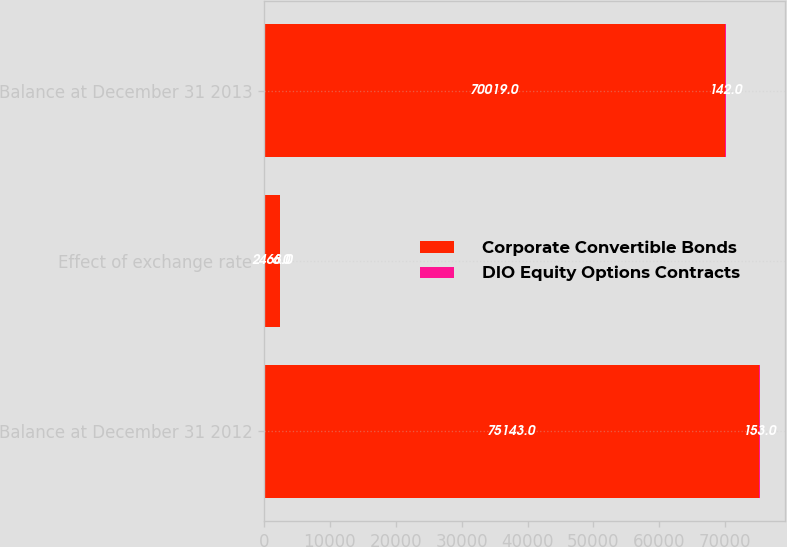Convert chart to OTSL. <chart><loc_0><loc_0><loc_500><loc_500><stacked_bar_chart><ecel><fcel>Balance at December 31 2012<fcel>Effect of exchange rate<fcel>Balance at December 31 2013<nl><fcel>Corporate Convertible Bonds<fcel>75143<fcel>2468<fcel>70019<nl><fcel>DIO Equity Options Contracts<fcel>153<fcel>6<fcel>142<nl></chart> 